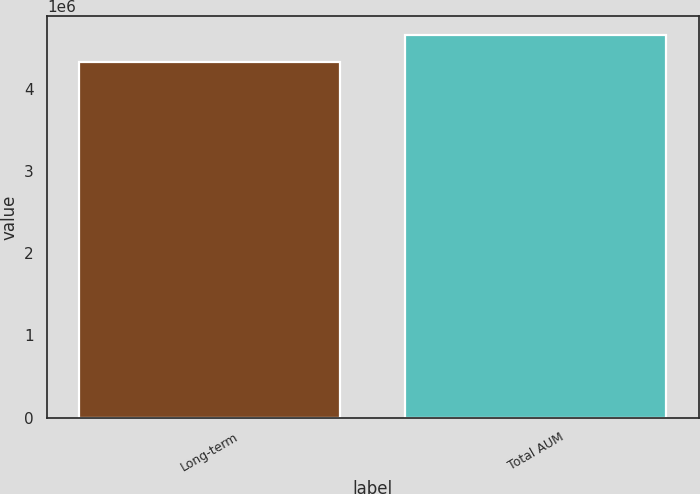Convert chart to OTSL. <chart><loc_0><loc_0><loc_500><loc_500><bar_chart><fcel>Long-term<fcel>Total AUM<nl><fcel>4.33384e+06<fcel>4.6519e+06<nl></chart> 